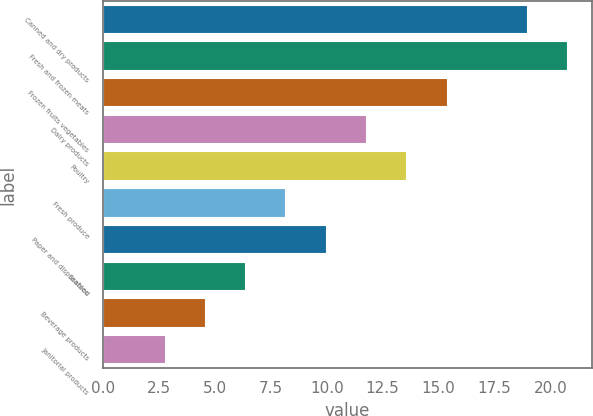Convert chart to OTSL. <chart><loc_0><loc_0><loc_500><loc_500><bar_chart><fcel>Canned and dry products<fcel>Fresh and frozen meats<fcel>Frozen fruits vegetables<fcel>Dairy products<fcel>Poultry<fcel>Fresh produce<fcel>Paper and disposables<fcel>Seafood<fcel>Beverage products<fcel>Janitorial products<nl><fcel>19<fcel>20.8<fcel>15.4<fcel>11.8<fcel>13.6<fcel>8.2<fcel>10<fcel>6.4<fcel>4.6<fcel>2.8<nl></chart> 